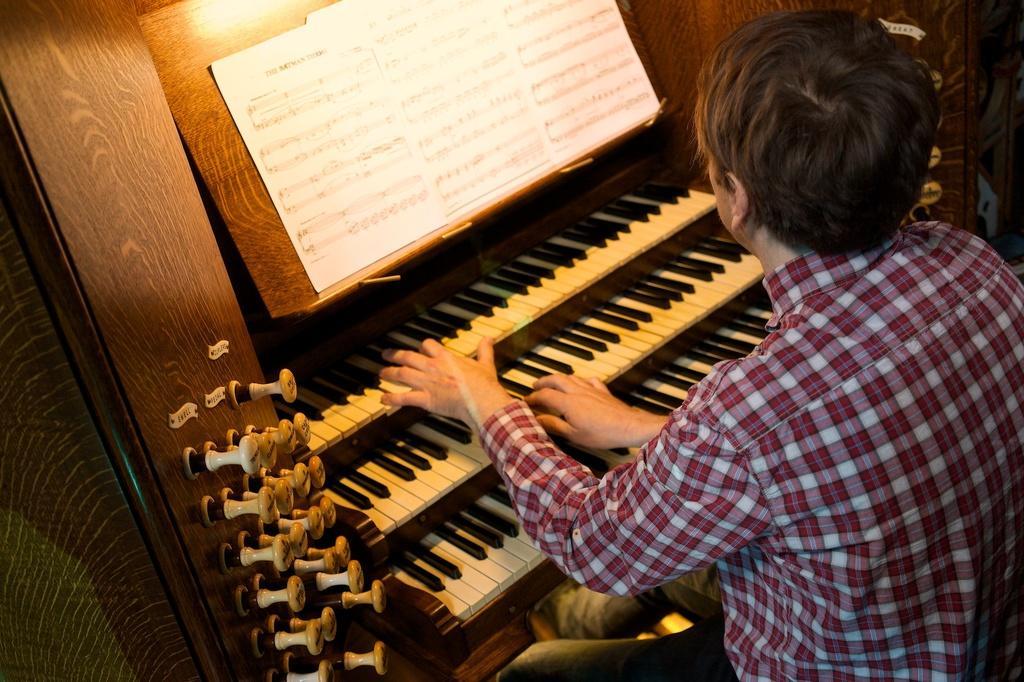In one or two sentences, can you explain what this image depicts? This man is sitting on a chair and playing this piano keyboard. On this piano keyboard there are papers with lyrics. These are keys in black and white color. These are buttons. 